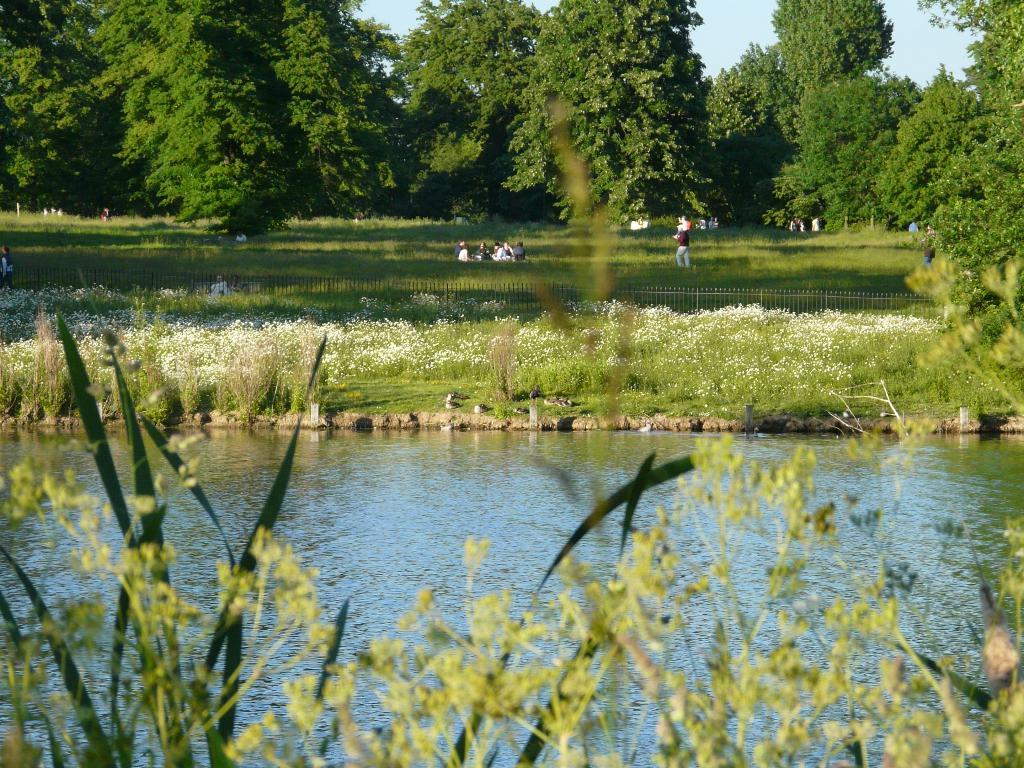What is the primary element in the image? There is water in the image. What other living organisms can be seen in the image? There are plants in the image. What can be seen in the background of the image? There is a fence, people, trees, and the sky visible in the background of the image. How many goldfish can be seen swimming in the water in the image? There are no goldfish present in the image; it only features water and plants. Can you tell me what type of bat is flying in the image? There is no bat present in the image. 